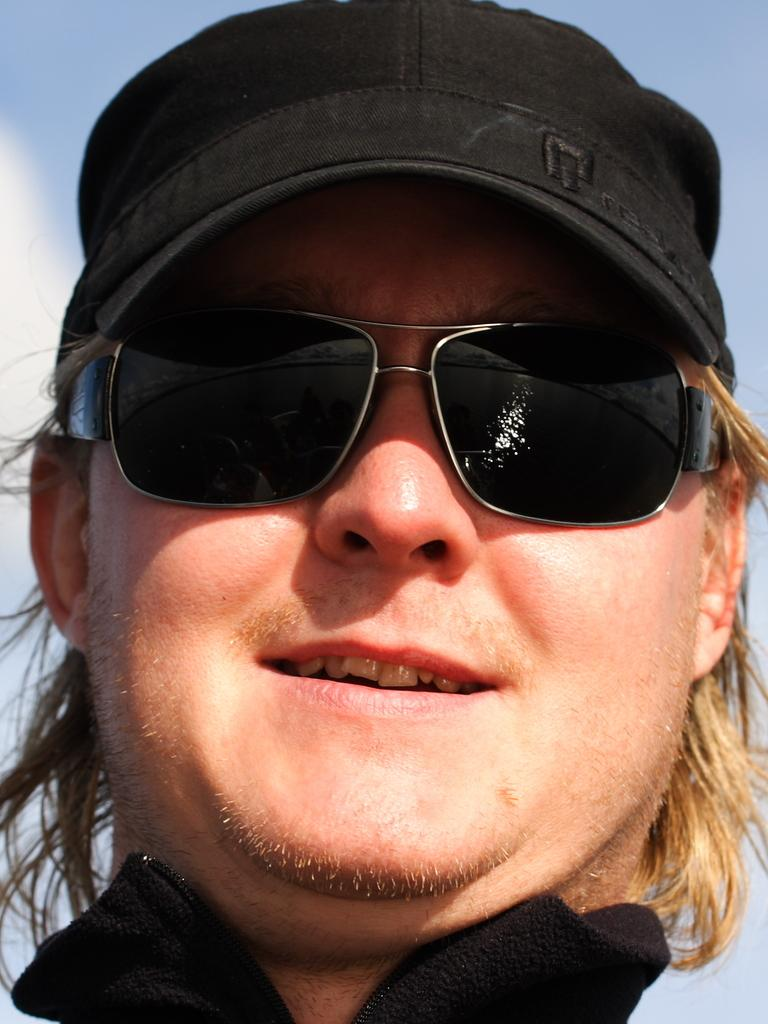What is the main subject of the image? The main subject of the image is a man. What is the man wearing on his upper body? The man is wearing a black T-shirt. What type of eyewear is the man wearing? The man is wearing goggles. What type of headwear is the man wearing? The man is wearing a black cap. What is the man's facial expression in the image? The man is smiling. What can be seen in the background of the image? The sky is visible in the background of the image. What is the color of the sky in the image? The color of the sky is blue. Can you see the man's mom in the image? There is no indication of the man's mom in the image. How many snails are crawling on the man's black cap in the image? There are no snails present in the image. What type of animal is standing next to the man in the image? There is no animal, such as a giraffe, present in the image. 